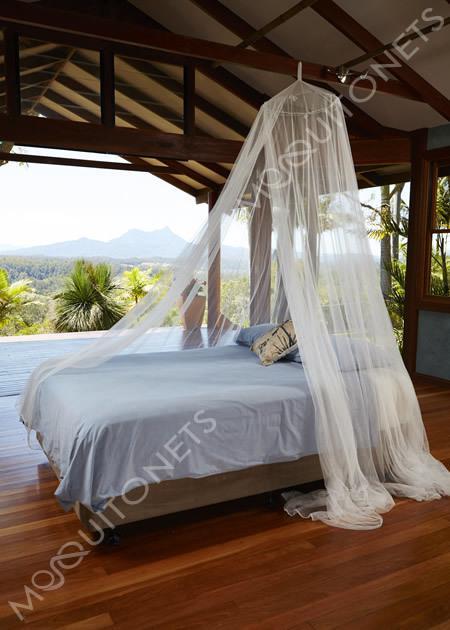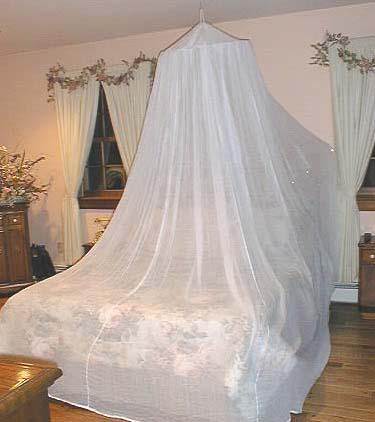The first image is the image on the left, the second image is the image on the right. For the images shown, is this caption "Some of the sheets are blue." true? Answer yes or no. Yes. The first image is the image on the left, the second image is the image on the right. Considering the images on both sides, is "There are two white pillows in the image to the right." valid? Answer yes or no. No. 